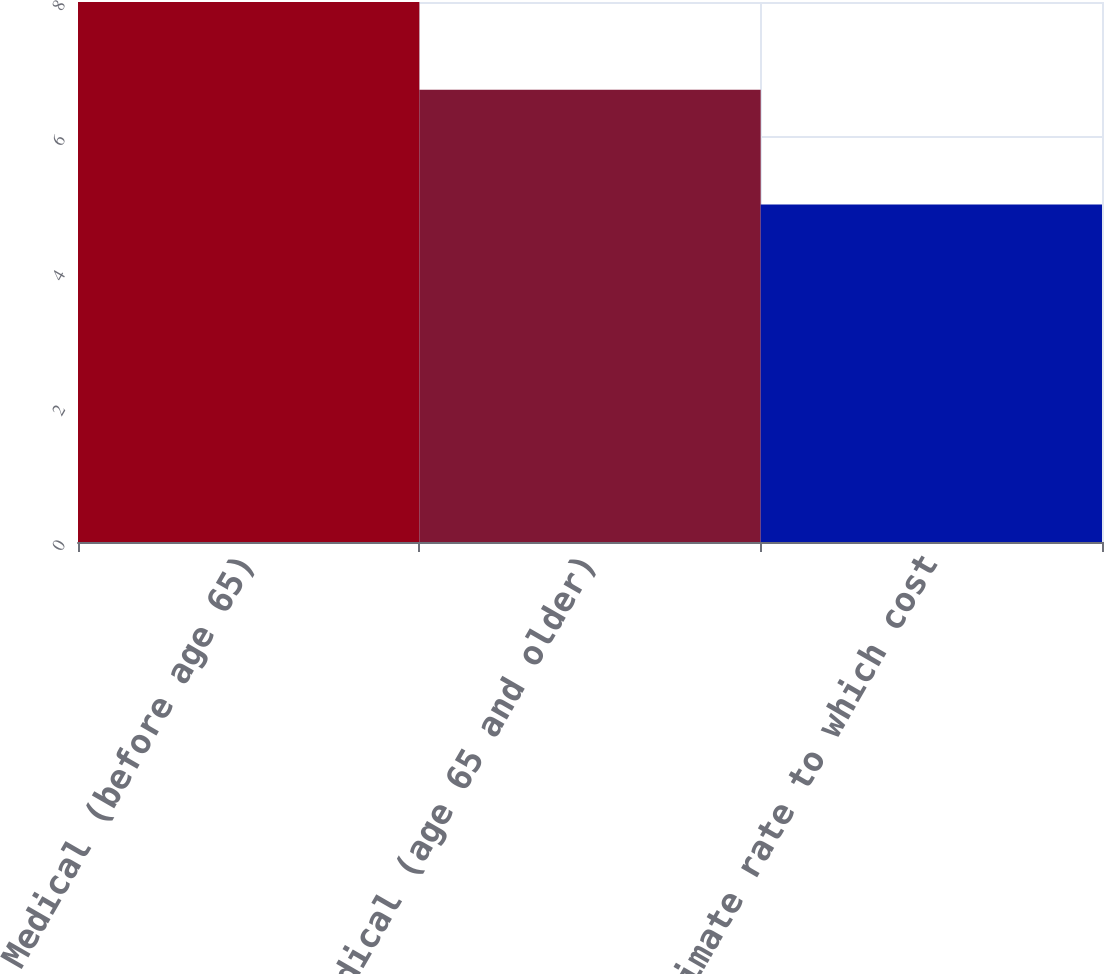<chart> <loc_0><loc_0><loc_500><loc_500><bar_chart><fcel>Medical (before age 65)<fcel>Medical (age 65 and older)<fcel>Ultimate rate to which cost<nl><fcel>8<fcel>6.7<fcel>5<nl></chart> 